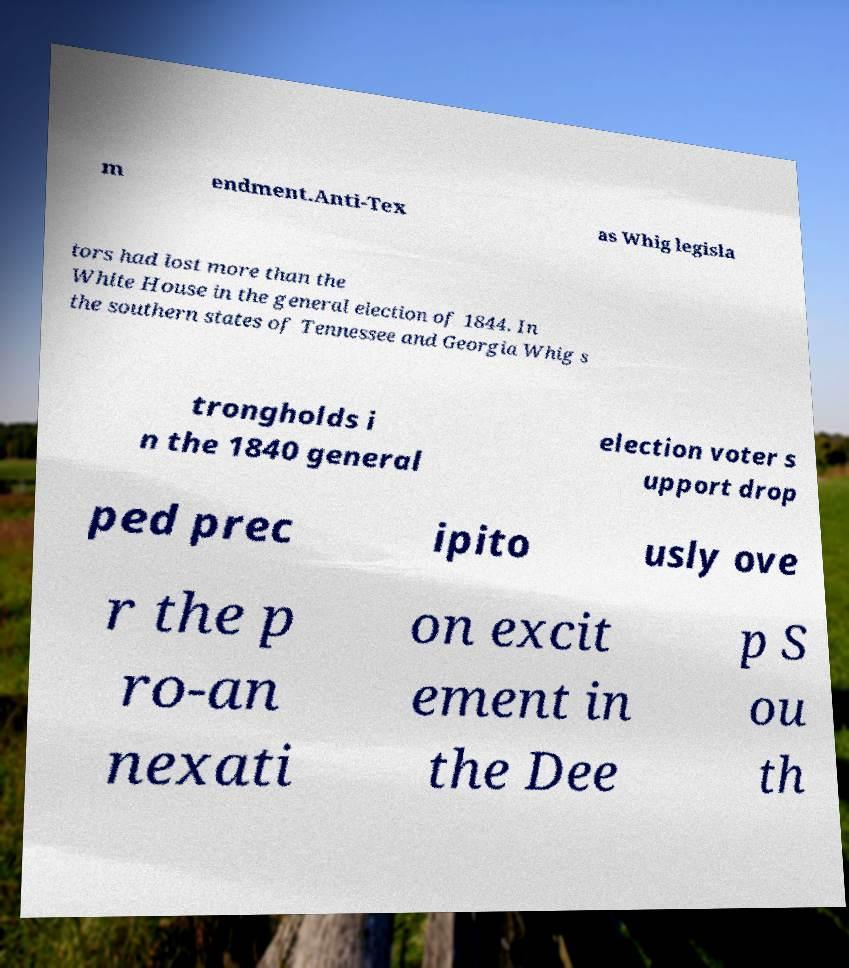What messages or text are displayed in this image? I need them in a readable, typed format. m endment.Anti-Tex as Whig legisla tors had lost more than the White House in the general election of 1844. In the southern states of Tennessee and Georgia Whig s trongholds i n the 1840 general election voter s upport drop ped prec ipito usly ove r the p ro-an nexati on excit ement in the Dee p S ou th 